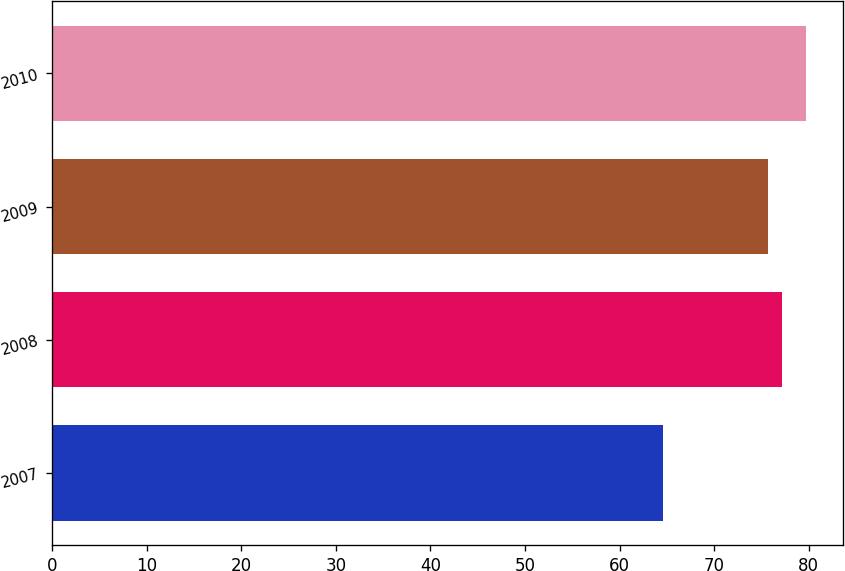Convert chart to OTSL. <chart><loc_0><loc_0><loc_500><loc_500><bar_chart><fcel>2007<fcel>2008<fcel>2009<fcel>2010<nl><fcel>64.6<fcel>77.21<fcel>75.7<fcel>79.7<nl></chart> 